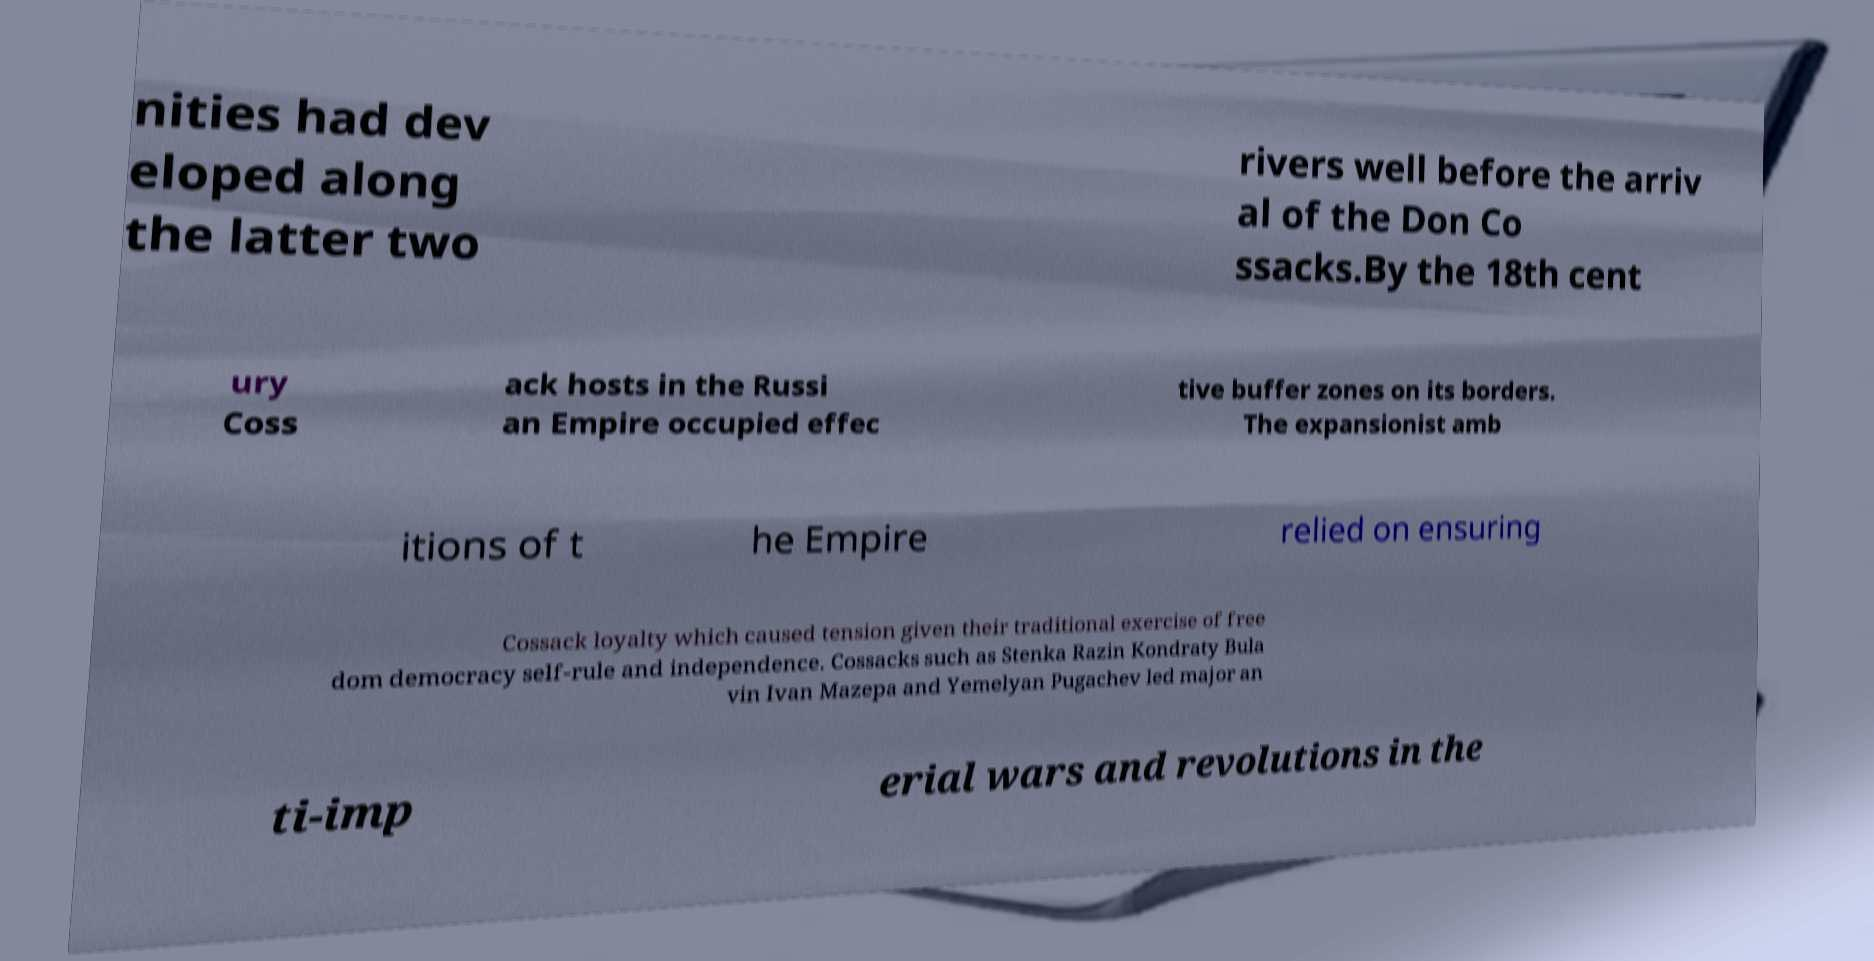Please identify and transcribe the text found in this image. nities had dev eloped along the latter two rivers well before the arriv al of the Don Co ssacks.By the 18th cent ury Coss ack hosts in the Russi an Empire occupied effec tive buffer zones on its borders. The expansionist amb itions of t he Empire relied on ensuring Cossack loyalty which caused tension given their traditional exercise of free dom democracy self-rule and independence. Cossacks such as Stenka Razin Kondraty Bula vin Ivan Mazepa and Yemelyan Pugachev led major an ti-imp erial wars and revolutions in the 